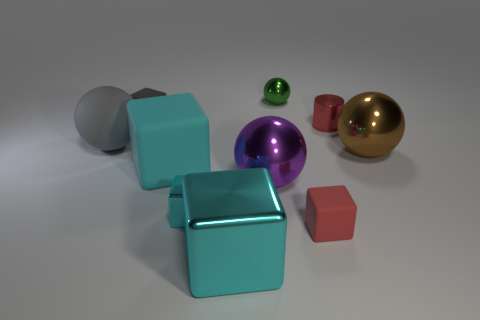Are there more cyan cubes than tiny purple shiny spheres?
Your answer should be very brief. Yes. Do the gray sphere and the small gray object have the same material?
Keep it short and to the point. No. What number of rubber objects are small red blocks or large blue cylinders?
Ensure brevity in your answer.  1. The metal cube that is the same size as the gray matte sphere is what color?
Your response must be concise. Cyan. What number of red matte things have the same shape as the tiny gray object?
Offer a terse response. 1. How many spheres are either small green things or red rubber objects?
Ensure brevity in your answer.  1. There is a object that is right of the tiny cylinder; does it have the same shape as the rubber thing left of the cyan rubber object?
Keep it short and to the point. Yes. What is the tiny cyan block made of?
Provide a succinct answer. Metal. The small metallic object that is the same color as the big rubber block is what shape?
Your response must be concise. Cube. What number of other balls are the same size as the gray ball?
Your answer should be compact. 2. 